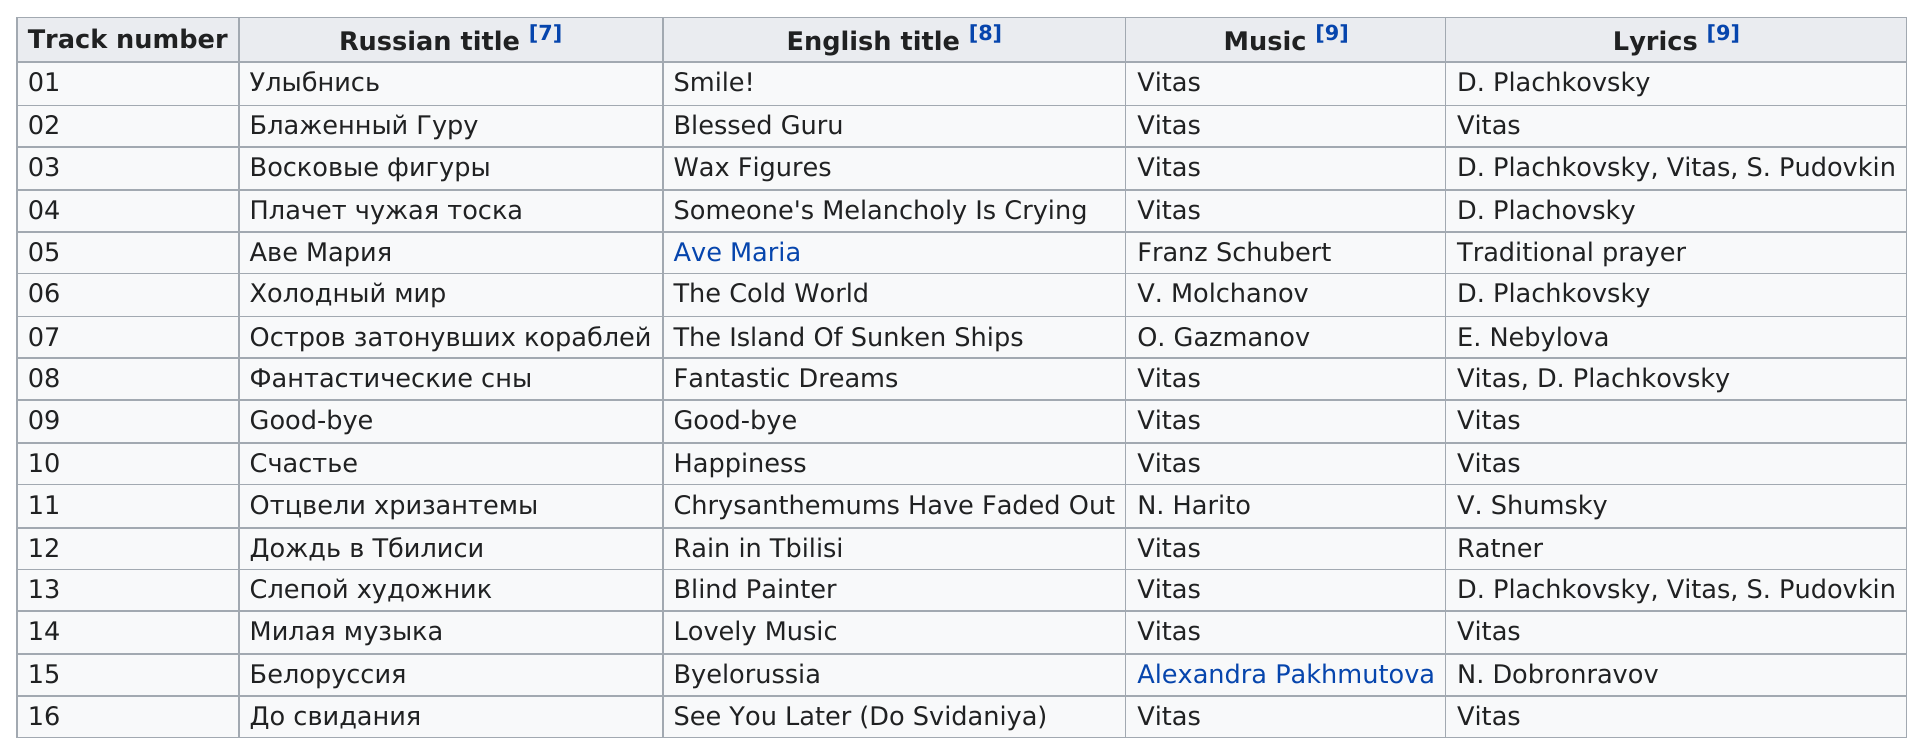Mention a couple of crucial points in this snapshot. Vitas is the lyricist with the largest amount of tracks. There are 11 tracks listed on the table that have been created by Vitas. The Russian title of track 03 is "Wax Figures", but the English title is unknown. Vitas' music had a total of 11 track numbers. Of the songs on the album Smile!, how many are not performed by Vitas? 